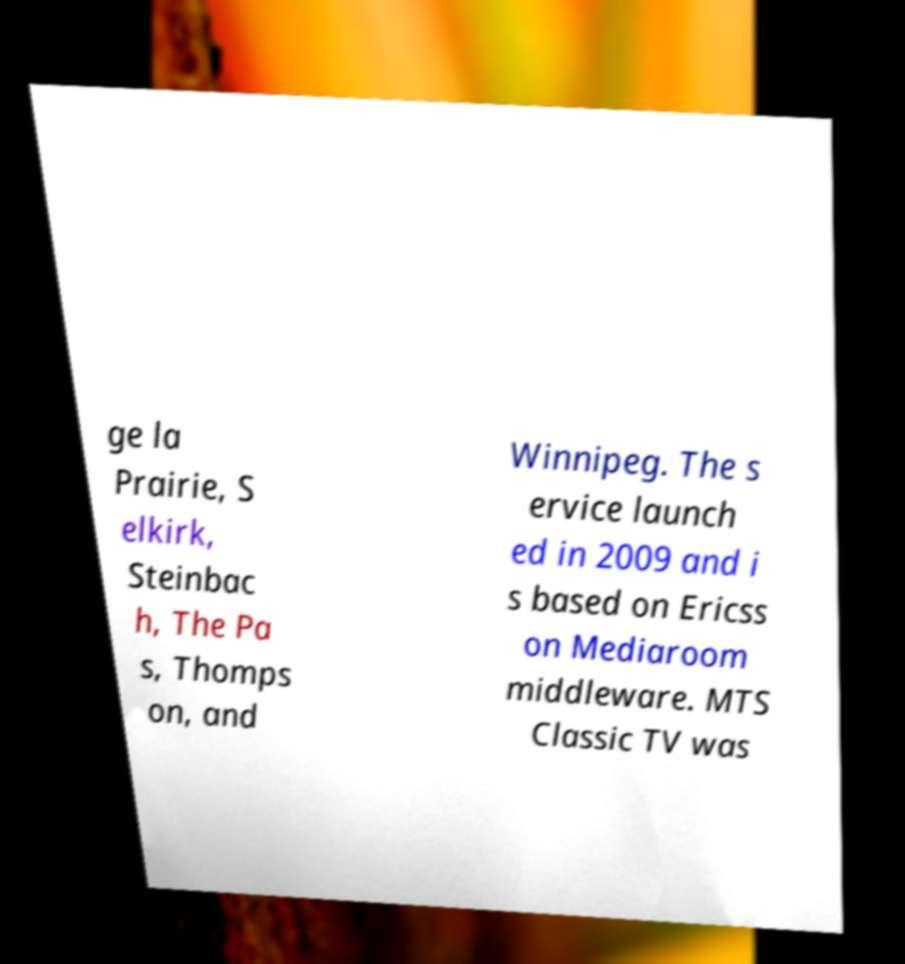There's text embedded in this image that I need extracted. Can you transcribe it verbatim? ge la Prairie, S elkirk, Steinbac h, The Pa s, Thomps on, and Winnipeg. The s ervice launch ed in 2009 and i s based on Ericss on Mediaroom middleware. MTS Classic TV was 